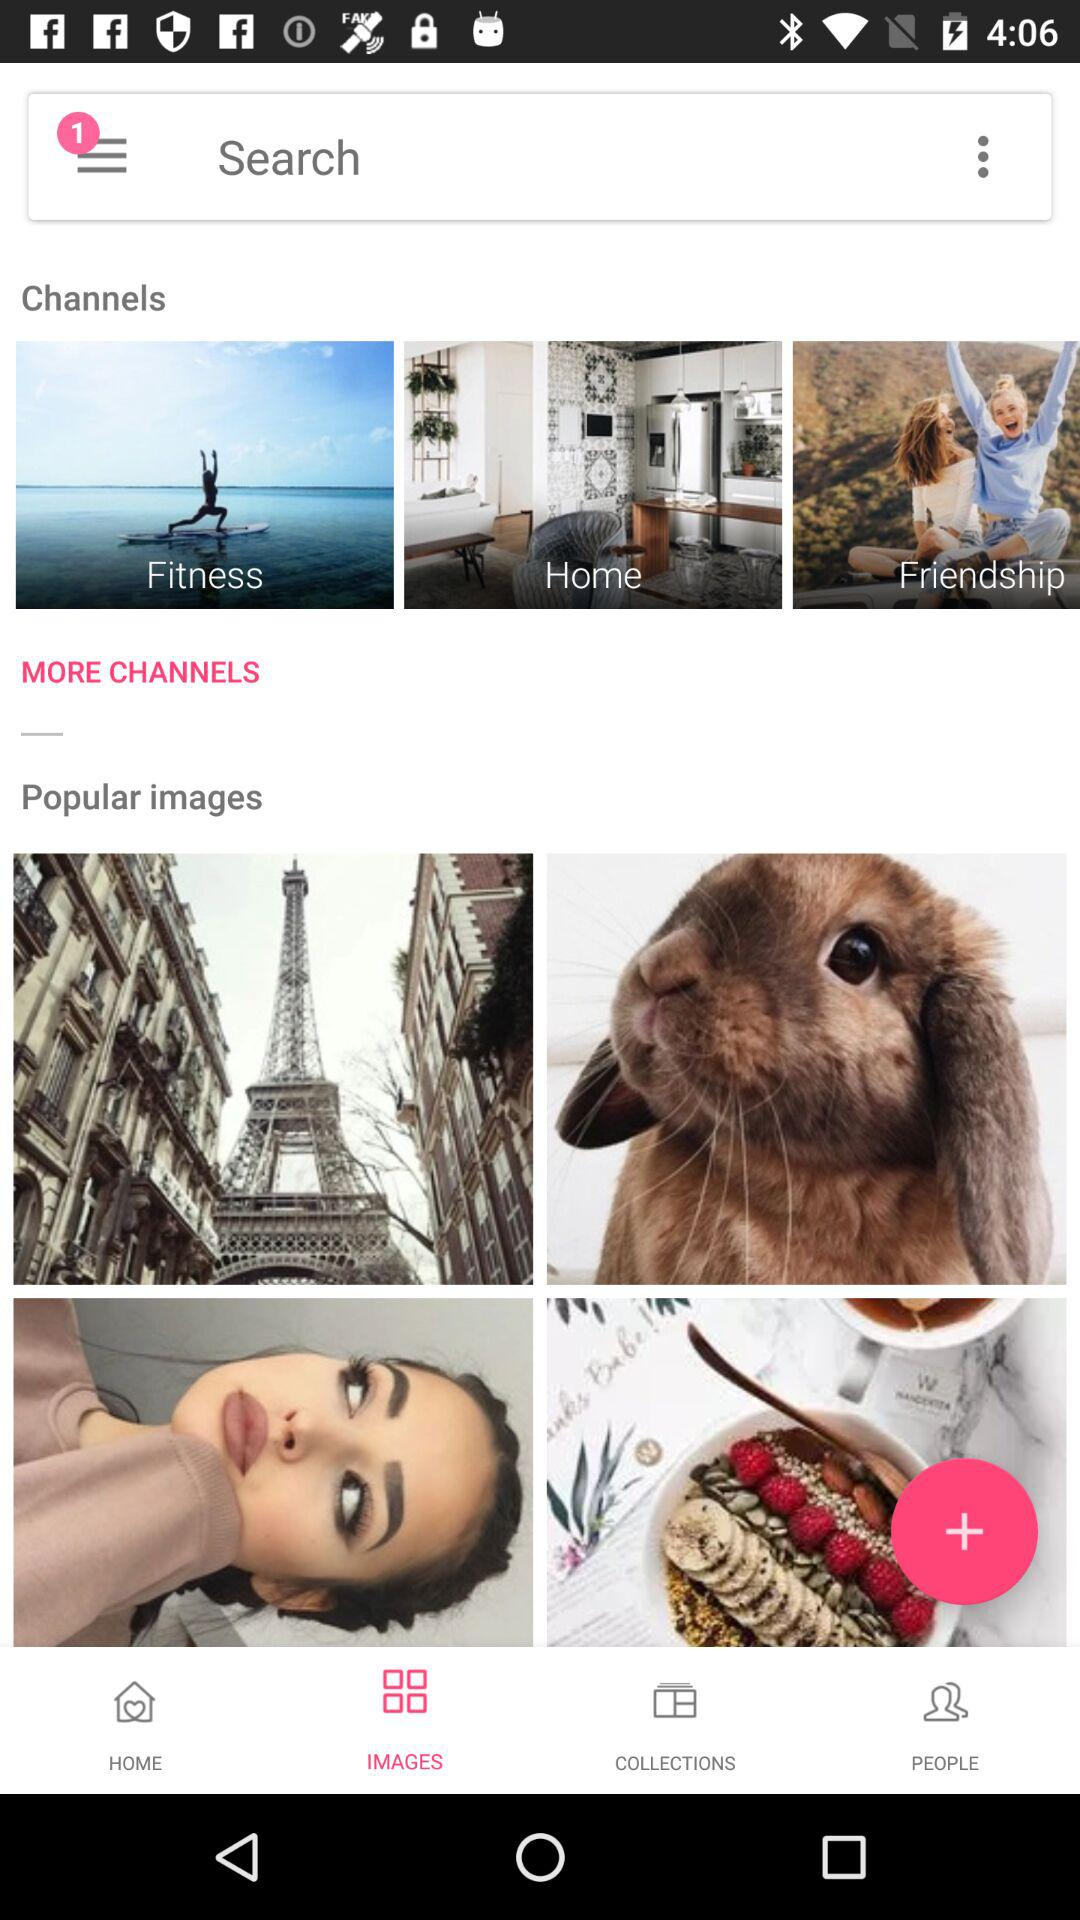What are the given channels? The given channels are "Fitness", "Home", and "Friendship". 